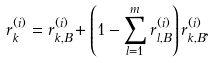<formula> <loc_0><loc_0><loc_500><loc_500>r _ { k } ^ { ( i ) } = r _ { k , B } ^ { ( i ) } + \left ( 1 - \sum _ { l = 1 } ^ { m } r _ { l , B } ^ { ( i ) } \right ) r _ { k , B } ^ { ( i ) } ,</formula> 